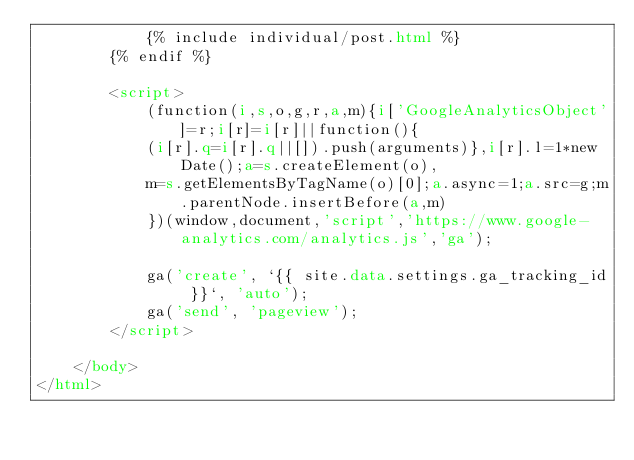<code> <loc_0><loc_0><loc_500><loc_500><_HTML_>            {% include individual/post.html %}
        {% endif %}

        <script>
            (function(i,s,o,g,r,a,m){i['GoogleAnalyticsObject']=r;i[r]=i[r]||function(){
            (i[r].q=i[r].q||[]).push(arguments)},i[r].l=1*new Date();a=s.createElement(o),
            m=s.getElementsByTagName(o)[0];a.async=1;a.src=g;m.parentNode.insertBefore(a,m)
            })(window,document,'script','https://www.google-analytics.com/analytics.js','ga');

            ga('create', `{{ site.data.settings.ga_tracking_id }}`, 'auto');
            ga('send', 'pageview');
        </script>

    </body>
</html>
</code> 